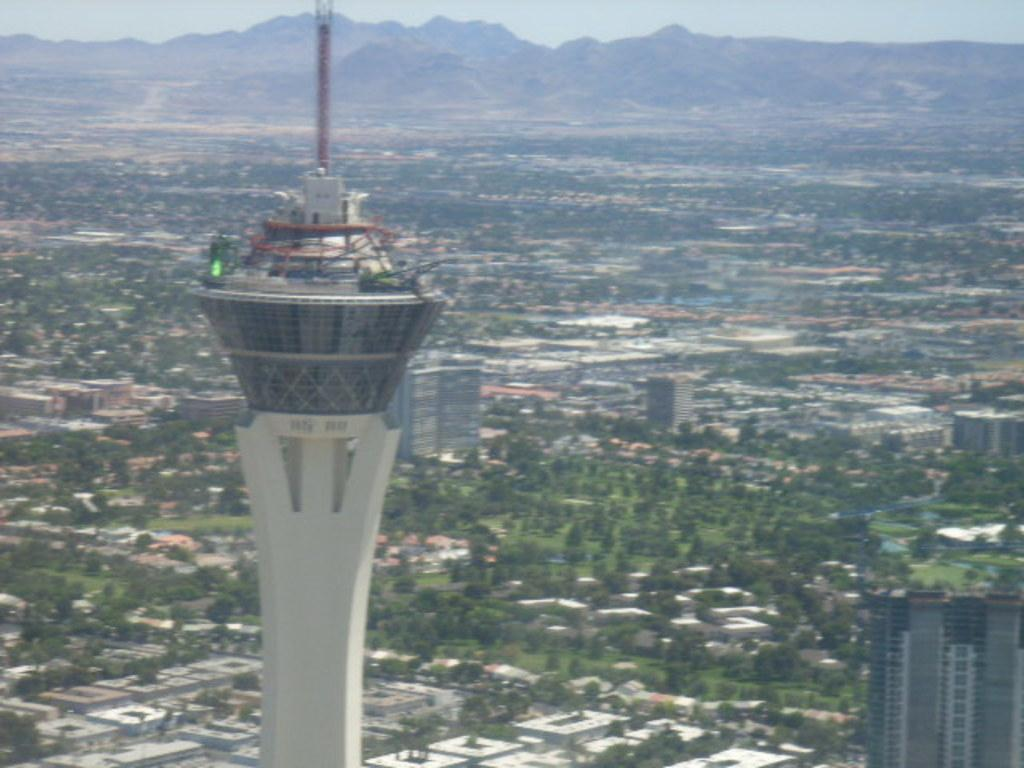What type of structures can be seen in the image? There are buildings in the image. What other natural elements are present in the image? There are trees in the image. What can be seen in the distance in the image? The sky is visible in the background of the image. Where is the nest of the bird in the image? There is no nest or bird present in the image. What type of shock can be seen in the image? There is no shock or electrical component present in the image. 